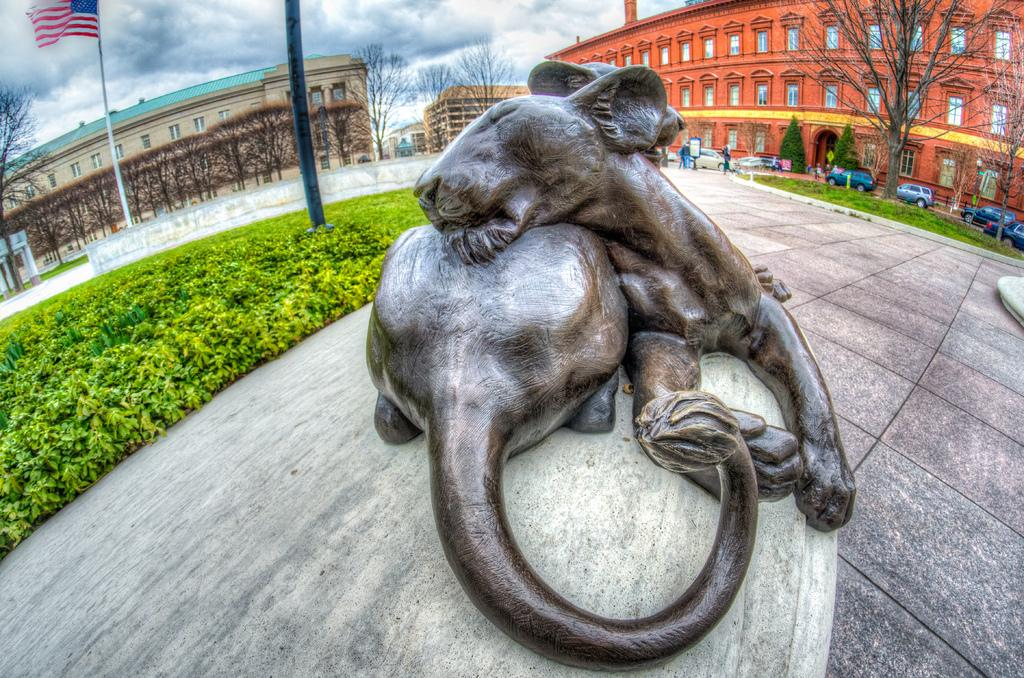What can be seen in the background of the image? In the background of the image, there are buildings, trees, vehicles, people, poles, and a flag. What type of plants are present in the image? There are plants in the image. What is the statue of in the image? The statue is of an animal. Where is the chair located in the image? There is no chair present in the image. What type of key is used to unlock the statue in the image? There is no key or locking mechanism present on the statue in the image. 